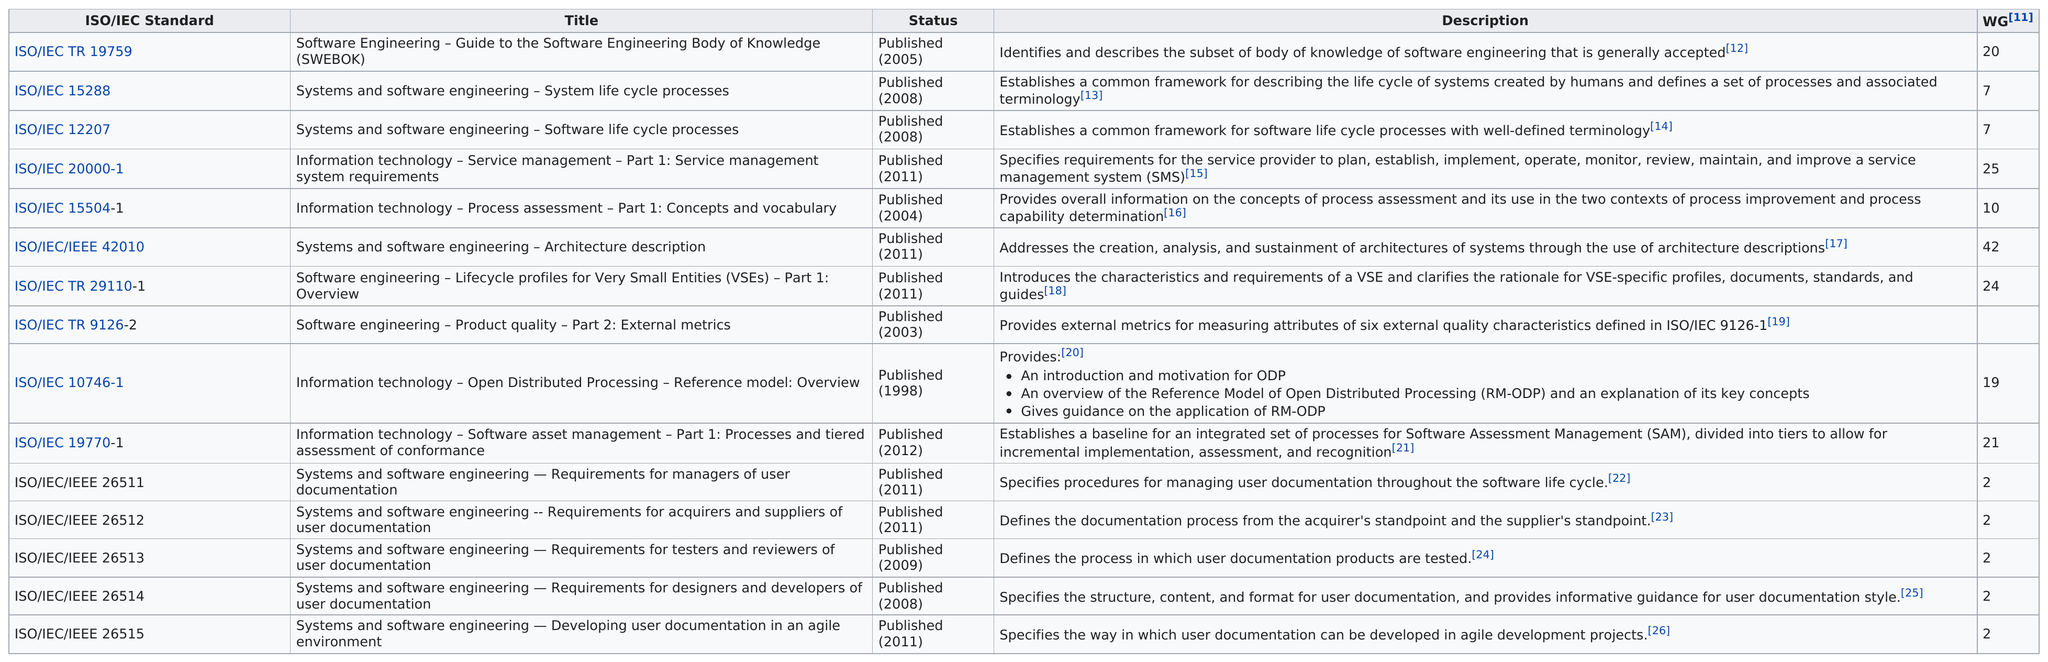Outline some significant characteristics in this image. The number of titles on the chart is either more or less than 24. In 2008, a total of 3 ISO/IEC publications were released. The last published standard is ISO/IEC 19770-1. In 2011, six ISO/IEC standards were published. In 2011, the total number of titles published was 6. 